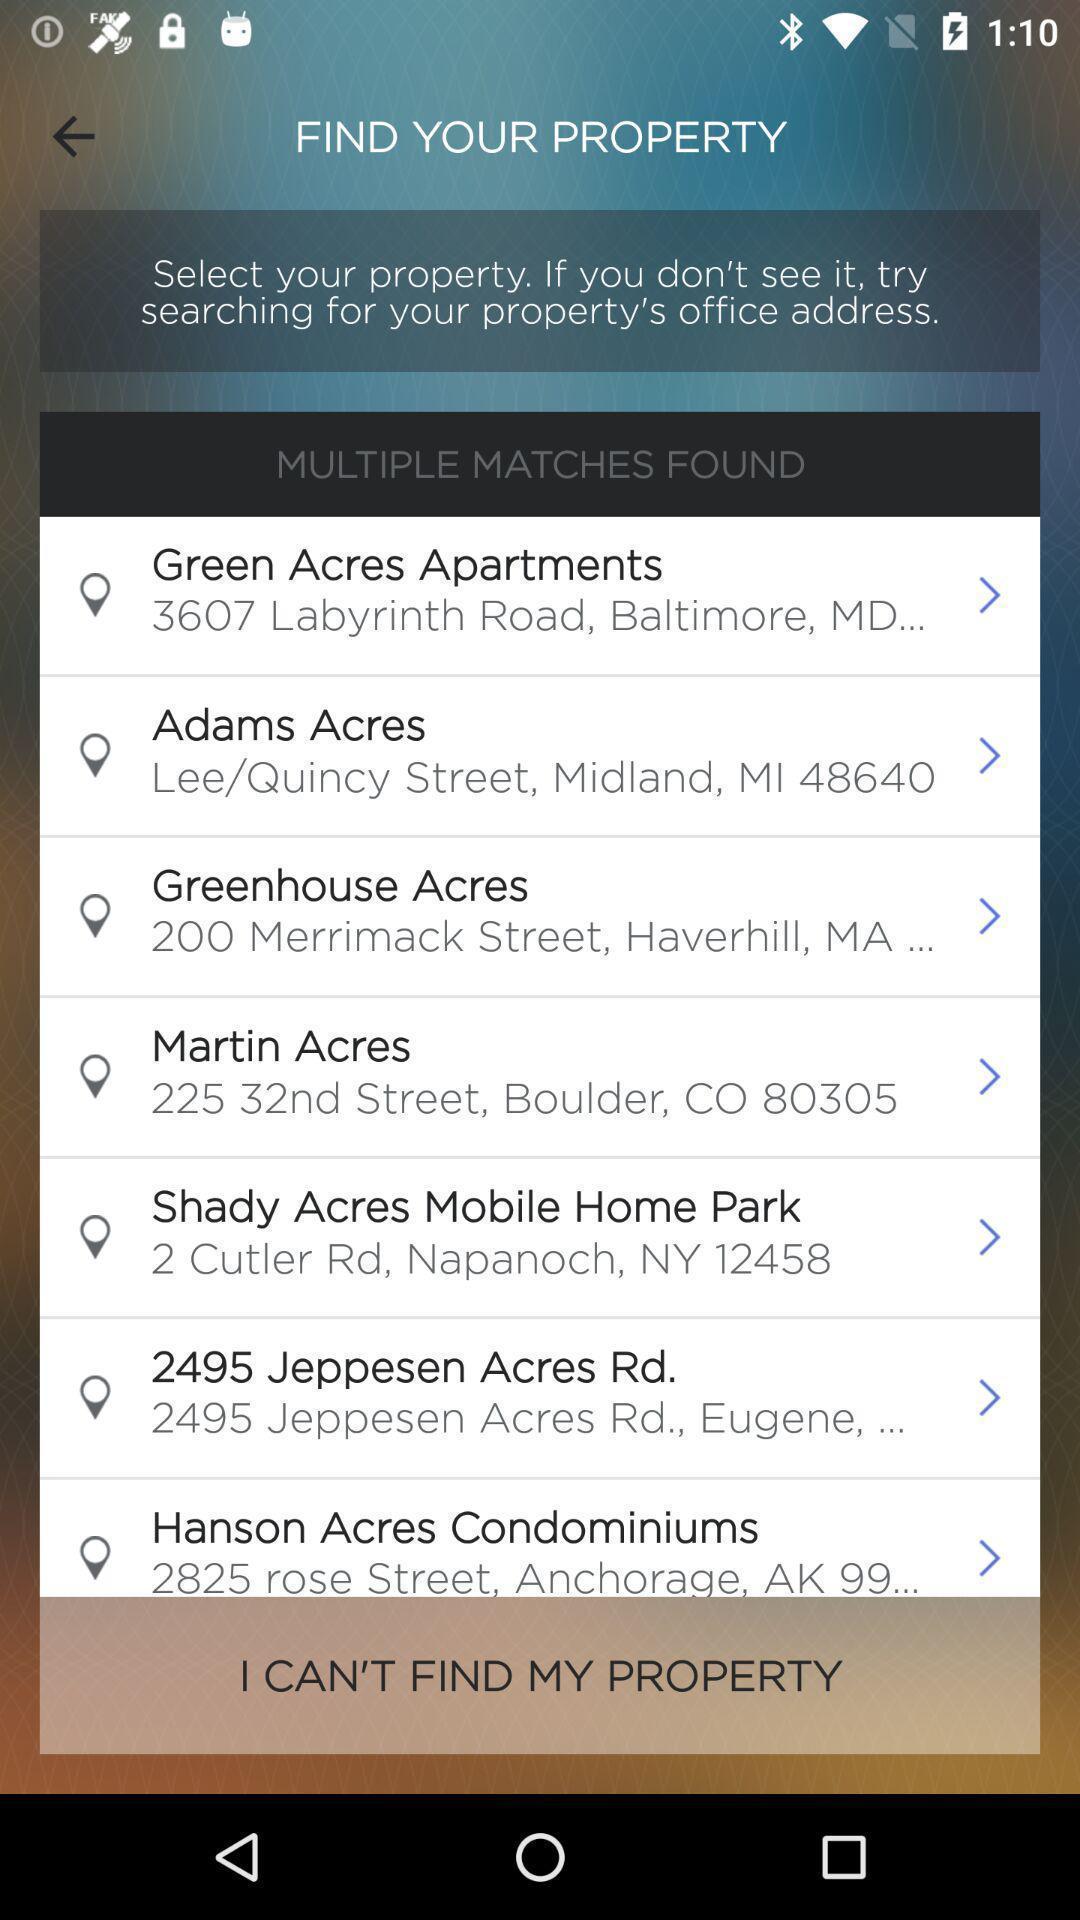Explain the elements present in this screenshot. Window displaying different properties to find. 